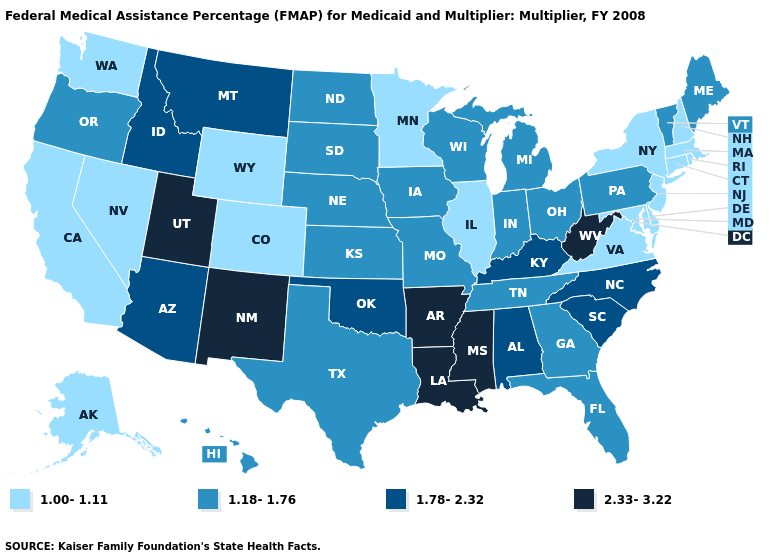Which states have the lowest value in the West?
Write a very short answer. Alaska, California, Colorado, Nevada, Washington, Wyoming. What is the lowest value in the MidWest?
Concise answer only. 1.00-1.11. Name the states that have a value in the range 1.00-1.11?
Give a very brief answer. Alaska, California, Colorado, Connecticut, Delaware, Illinois, Maryland, Massachusetts, Minnesota, Nevada, New Hampshire, New Jersey, New York, Rhode Island, Virginia, Washington, Wyoming. Which states hav the highest value in the MidWest?
Write a very short answer. Indiana, Iowa, Kansas, Michigan, Missouri, Nebraska, North Dakota, Ohio, South Dakota, Wisconsin. What is the value of North Dakota?
Concise answer only. 1.18-1.76. Does the first symbol in the legend represent the smallest category?
Give a very brief answer. Yes. What is the value of New York?
Keep it brief. 1.00-1.11. Which states have the lowest value in the USA?
Give a very brief answer. Alaska, California, Colorado, Connecticut, Delaware, Illinois, Maryland, Massachusetts, Minnesota, Nevada, New Hampshire, New Jersey, New York, Rhode Island, Virginia, Washington, Wyoming. Which states have the lowest value in the USA?
Concise answer only. Alaska, California, Colorado, Connecticut, Delaware, Illinois, Maryland, Massachusetts, Minnesota, Nevada, New Hampshire, New Jersey, New York, Rhode Island, Virginia, Washington, Wyoming. Among the states that border Alabama , which have the highest value?
Give a very brief answer. Mississippi. Which states hav the highest value in the West?
Quick response, please. New Mexico, Utah. Which states have the lowest value in the USA?
Answer briefly. Alaska, California, Colorado, Connecticut, Delaware, Illinois, Maryland, Massachusetts, Minnesota, Nevada, New Hampshire, New Jersey, New York, Rhode Island, Virginia, Washington, Wyoming. Which states hav the highest value in the South?
Answer briefly. Arkansas, Louisiana, Mississippi, West Virginia. What is the value of Washington?
Quick response, please. 1.00-1.11. What is the value of North Dakota?
Quick response, please. 1.18-1.76. 